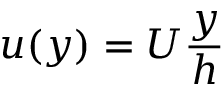<formula> <loc_0><loc_0><loc_500><loc_500>u ( y ) = U { \frac { y } { h } }</formula> 